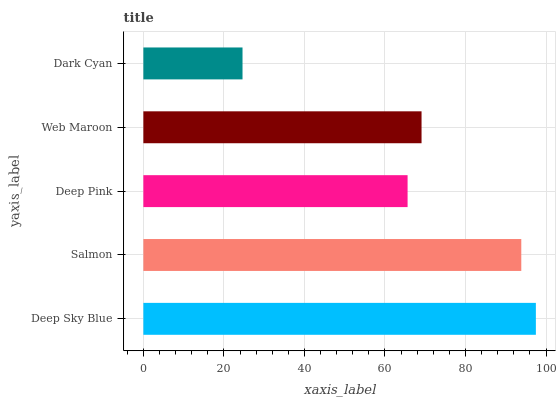Is Dark Cyan the minimum?
Answer yes or no. Yes. Is Deep Sky Blue the maximum?
Answer yes or no. Yes. Is Salmon the minimum?
Answer yes or no. No. Is Salmon the maximum?
Answer yes or no. No. Is Deep Sky Blue greater than Salmon?
Answer yes or no. Yes. Is Salmon less than Deep Sky Blue?
Answer yes or no. Yes. Is Salmon greater than Deep Sky Blue?
Answer yes or no. No. Is Deep Sky Blue less than Salmon?
Answer yes or no. No. Is Web Maroon the high median?
Answer yes or no. Yes. Is Web Maroon the low median?
Answer yes or no. Yes. Is Deep Pink the high median?
Answer yes or no. No. Is Deep Sky Blue the low median?
Answer yes or no. No. 